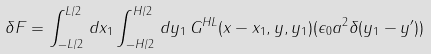Convert formula to latex. <formula><loc_0><loc_0><loc_500><loc_500>\delta F = \int ^ { L / 2 } _ { - L / 2 } \, d x _ { 1 } \int ^ { H / 2 } _ { - H / 2 } \, d y _ { 1 } \, G ^ { H L } ( x - x _ { 1 } , y , y _ { 1 } ) ( \epsilon _ { 0 } a ^ { 2 } \delta ( y _ { 1 } - y ^ { \prime } ) )</formula> 